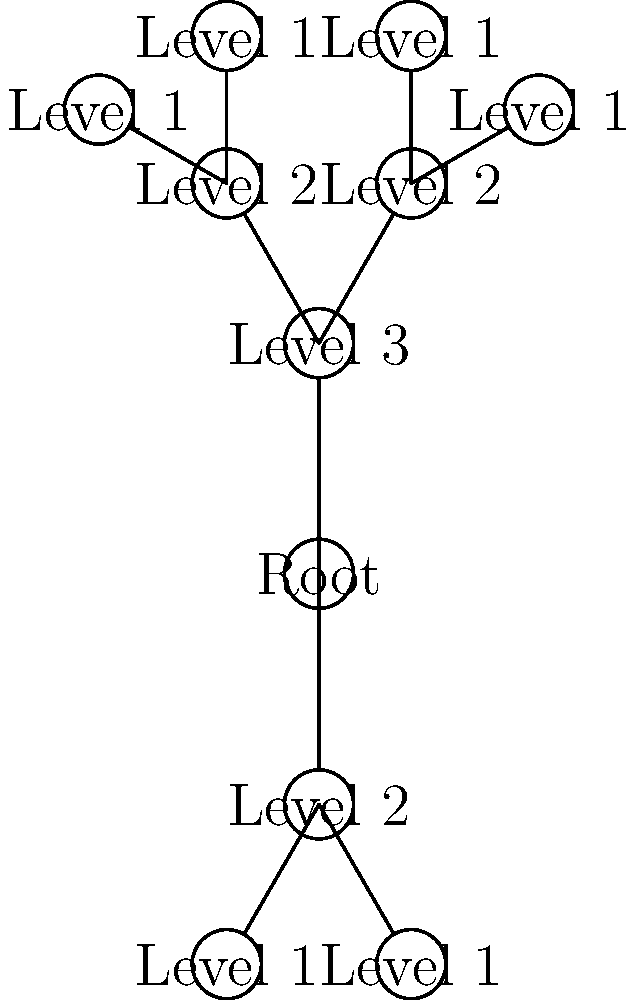Based on the tree diagram representing nested log levels, what is the maximum depth of logging levels visualized? To determine the maximum depth of logging levels visualized in the tree diagram, we need to follow these steps:

1. Identify the root node: The root node is labeled "Root" and represents the starting point of the logging hierarchy.

2. Count the levels from the root:
   - Level 1: Directly connected to the root, labeled "Level 3"
   - Level 2: Connected to "Level 3", labeled "Level 2"
   - Level 3: Connected to "Level 2", labeled "Level 1"

3. Observe the branches:
   - The upper branch (extending upwards from the root) has 3 levels of depth.
   - The lower branch (extending downwards from the root) has 2 levels of depth.

4. Determine the maximum depth:
   The maximum depth is the longest path from the root to a leaf node. In this case, it's the upper branch with 3 levels.

5. Calculate the total depth:
   Root level (1) + Maximum branch depth (3) = 4 levels in total

Therefore, the maximum depth of logging levels visualized in the tree diagram is 4.
Answer: 4 